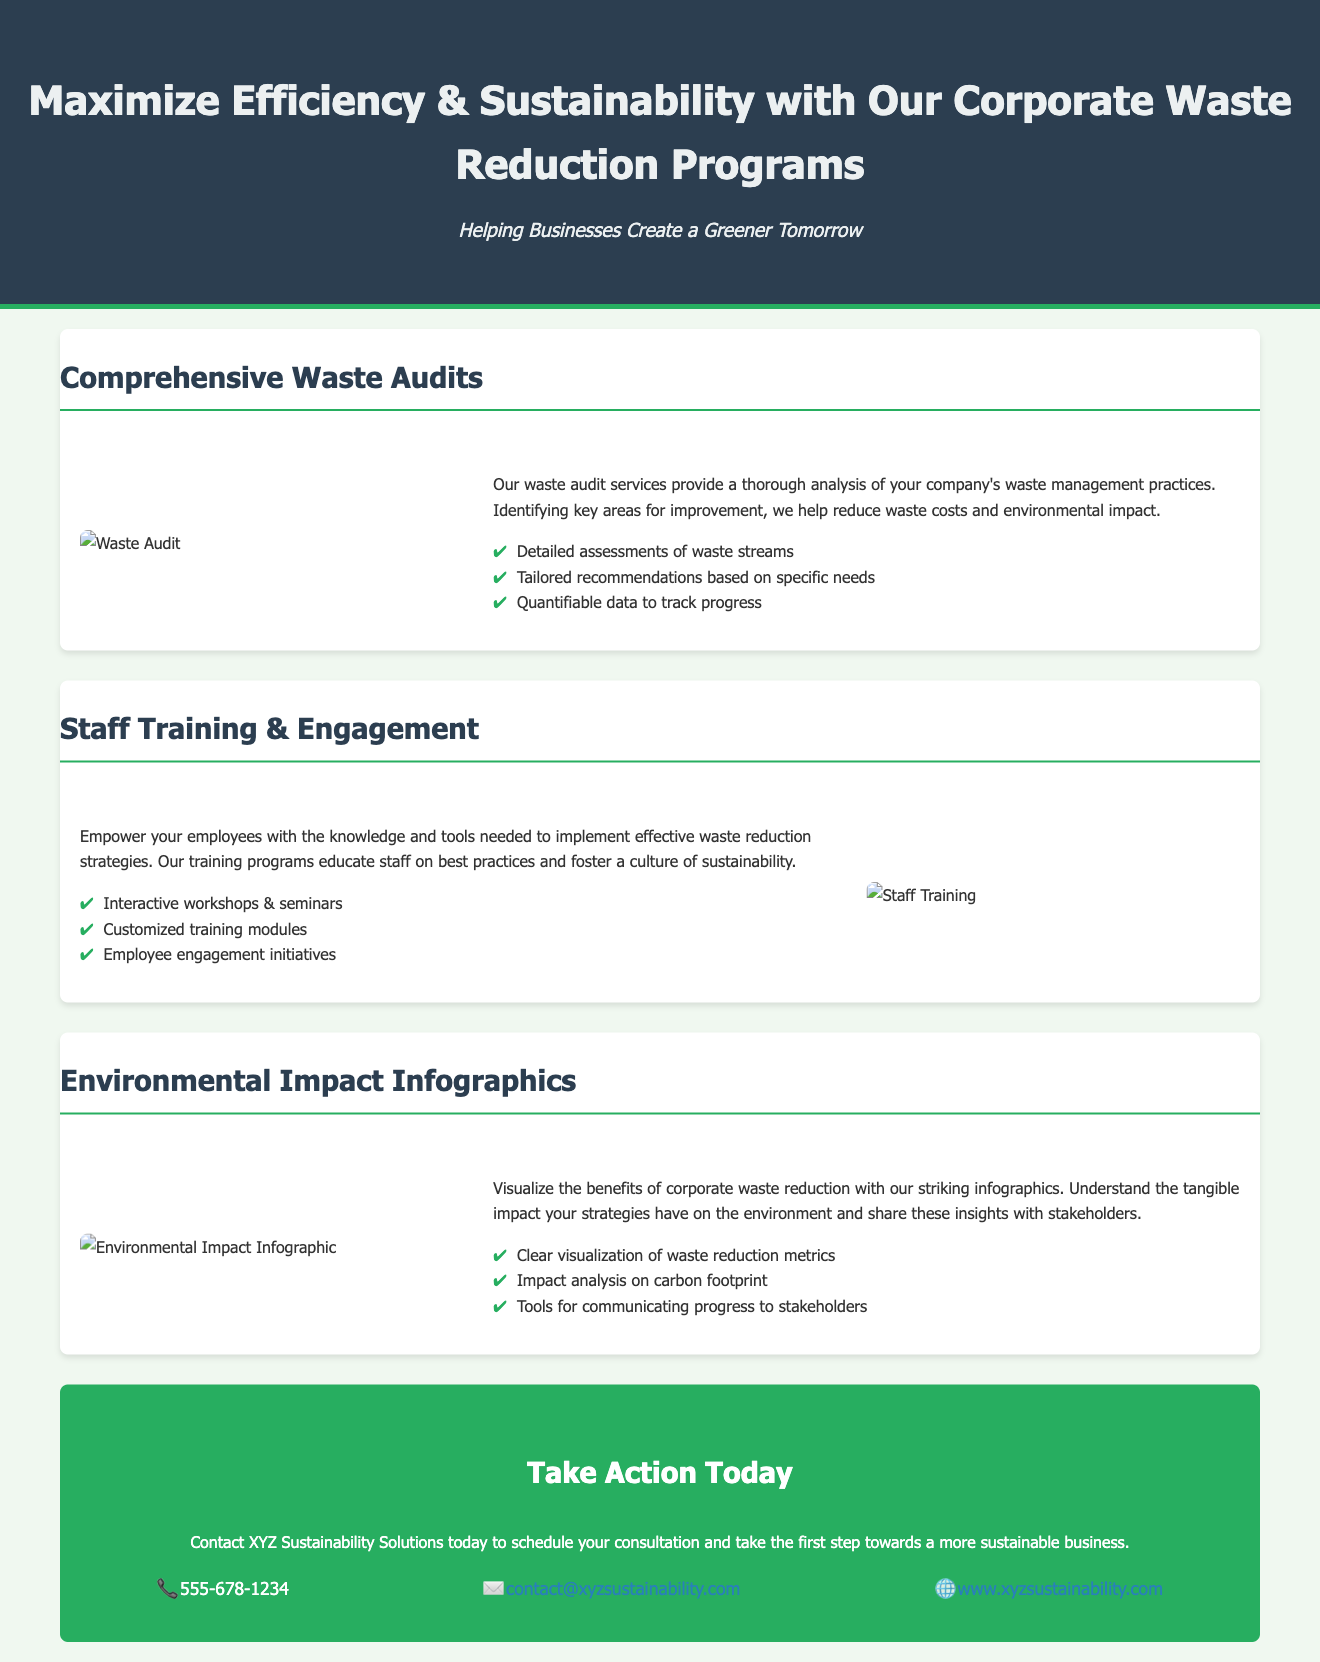What is the title of the advertisement? The title of the advertisement is presented prominently in the header section.
Answer: Maximize Efficiency & Sustainability with Our Corporate Waste Reduction Programs What is the subtitle of the advertisement? The subtitle follows the title and provides additional context about the service offered.
Answer: Helping Businesses Create a Greener Tomorrow What are the services offered in the waste audits section? The document lists specific services provided in the waste audits section in bullet points.
Answer: Detailed assessments of waste streams, Tailored recommendations based on specific needs, Quantifiable data to track progress How many sections are there in the advertisement? The advertisement contains a specific number of distinct sections, each showcasing different services.
Answer: Three What is the main contact number listed in the advertisement? The advertisement provides contact information, including a phone number.
Answer: 555-678-1234 What type of training programs are mentioned? The advertisement describes the staff training programs and specifies their educational nature.
Answer: Interactive workshops & seminars How does the advertisement encourage action? The advertisement has a specific call to action aimed at motivating readers to take the next step.
Answer: Take Action Today What is the website link provided in the contact information? The contact information includes a link to the company's website for further inquiry.
Answer: www.xyzsustainability.com What benefit do the environmental impact infographics provide? The infographics are mentioned to help visualize the benefits.
Answer: Clear visualization of waste reduction metrics 